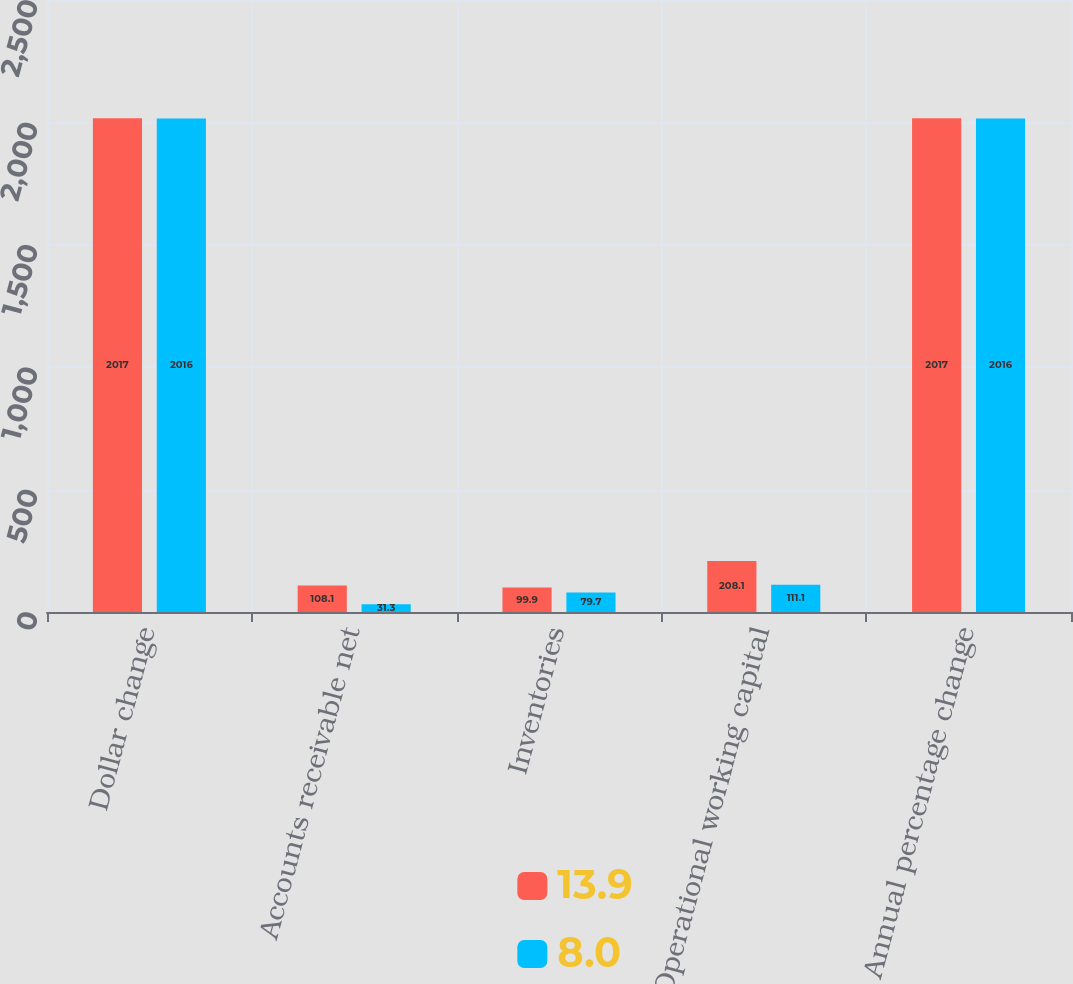Convert chart to OTSL. <chart><loc_0><loc_0><loc_500><loc_500><stacked_bar_chart><ecel><fcel>Dollar change<fcel>Accounts receivable net<fcel>Inventories<fcel>Operational working capital<fcel>Annual percentage change<nl><fcel>13.9<fcel>2017<fcel>108.1<fcel>99.9<fcel>208.1<fcel>2017<nl><fcel>8<fcel>2016<fcel>31.3<fcel>79.7<fcel>111.1<fcel>2016<nl></chart> 